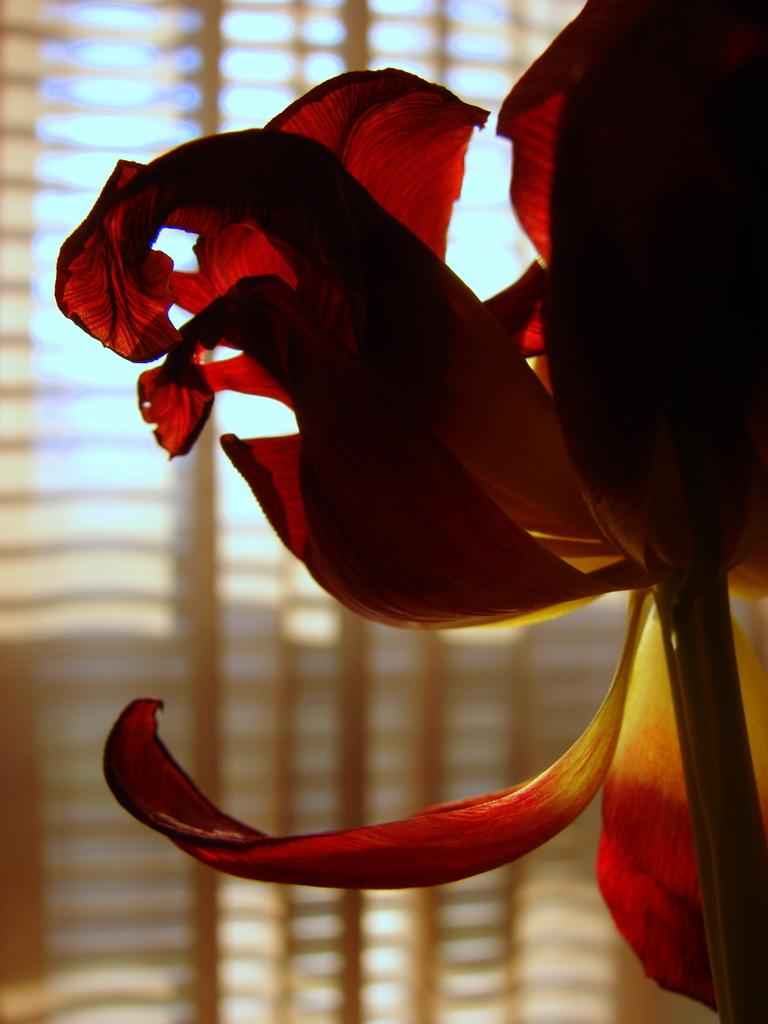Where was the image taken? The image was taken indoors. What can be seen in the background of the image? There is a window in the background of the image. What is present near the window? There is a window blind in the image. What type of object can be seen on the right side of the image? There is a flower on the right side of the image. What type of ornament is hanging from the ceiling in the image? There is no ornament hanging from the ceiling in the image. What team is playing in the background of the image? There is no team playing in the background of the image; it is an indoor setting with a window and a flower. 